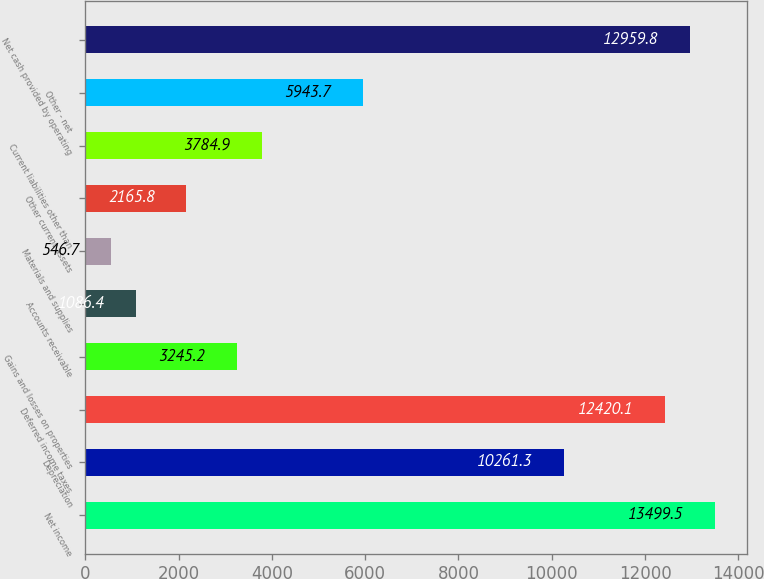<chart> <loc_0><loc_0><loc_500><loc_500><bar_chart><fcel>Net income<fcel>Depreciation<fcel>Deferred income taxes<fcel>Gains and losses on properties<fcel>Accounts receivable<fcel>Materials and supplies<fcel>Other current assets<fcel>Current liabilities other than<fcel>Other - net<fcel>Net cash provided by operating<nl><fcel>13499.5<fcel>10261.3<fcel>12420.1<fcel>3245.2<fcel>1086.4<fcel>546.7<fcel>2165.8<fcel>3784.9<fcel>5943.7<fcel>12959.8<nl></chart> 